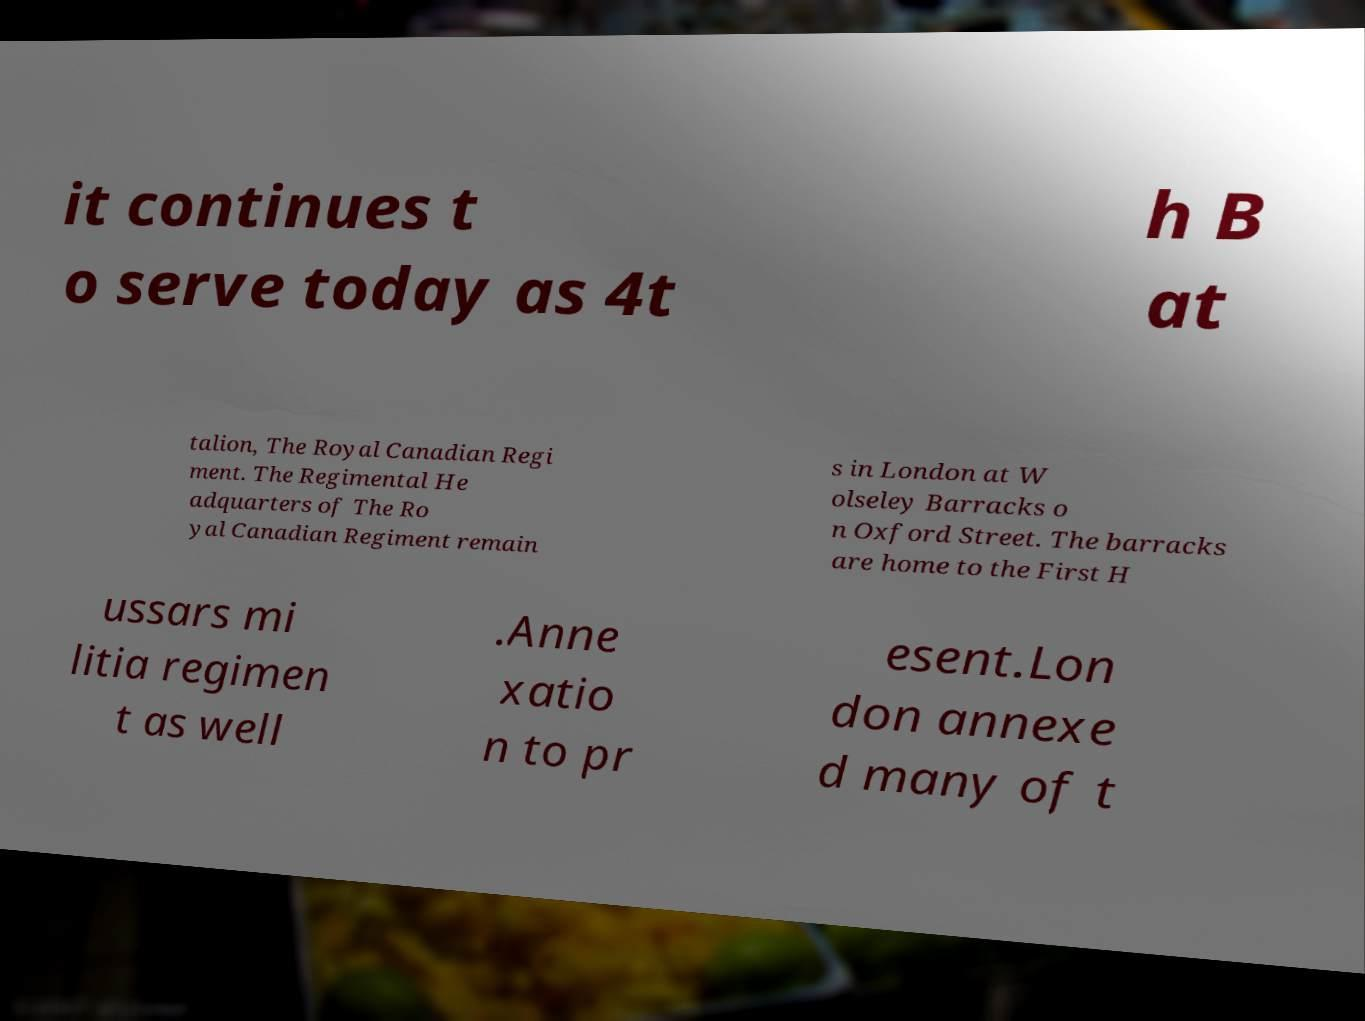Could you extract and type out the text from this image? it continues t o serve today as 4t h B at talion, The Royal Canadian Regi ment. The Regimental He adquarters of The Ro yal Canadian Regiment remain s in London at W olseley Barracks o n Oxford Street. The barracks are home to the First H ussars mi litia regimen t as well .Anne xatio n to pr esent.Lon don annexe d many of t 